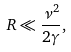<formula> <loc_0><loc_0><loc_500><loc_500>R \ll \frac { \nu ^ { 2 } } { 2 \gamma } ,</formula> 